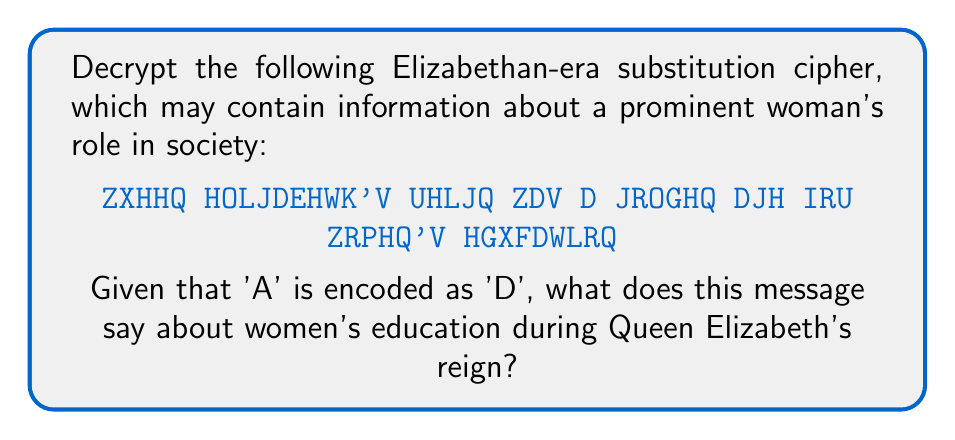Give your solution to this math problem. To decrypt this substitution cipher, we need to follow these steps:

1. Identify the shift: We're told that 'A' is encoded as 'D'. This means the alphabet has been shifted by 3 letters.

2. Create a decryption key:
   Plain:  A B C D E F G H I J K L M N O P Q R S T U V W X Y Z
   Cipher: D E F G H I J K L M N O P Q R S T U V W X Y Z A B C

3. Decrypt each letter by shifting it back 3 positions in the alphabet:

   Z -> W
   X -> U
   H -> E
   Q -> N
   
   E -> B
   L -> I
   J -> G
   D -> A
   
   And so on...

4. Decrypting the full message:

   ZXHHQ HOLJDEHWK'V UHLJQ ZDV D JROGHQ DJH IRU ZRPHQ'V HGXFDWLRQ
   QUEEN ELIZABETH'S REIGN WAS A GOLDEN AGE FOR WOMEN'S EDUCATION

5. Interpreting the message:
   The decrypted message states that Queen Elizabeth's reign was a golden age for women's education, which is directly relevant to the role of women in Elizabethan society.
Answer: Queen Elizabeth's reign was a golden age for women's education 